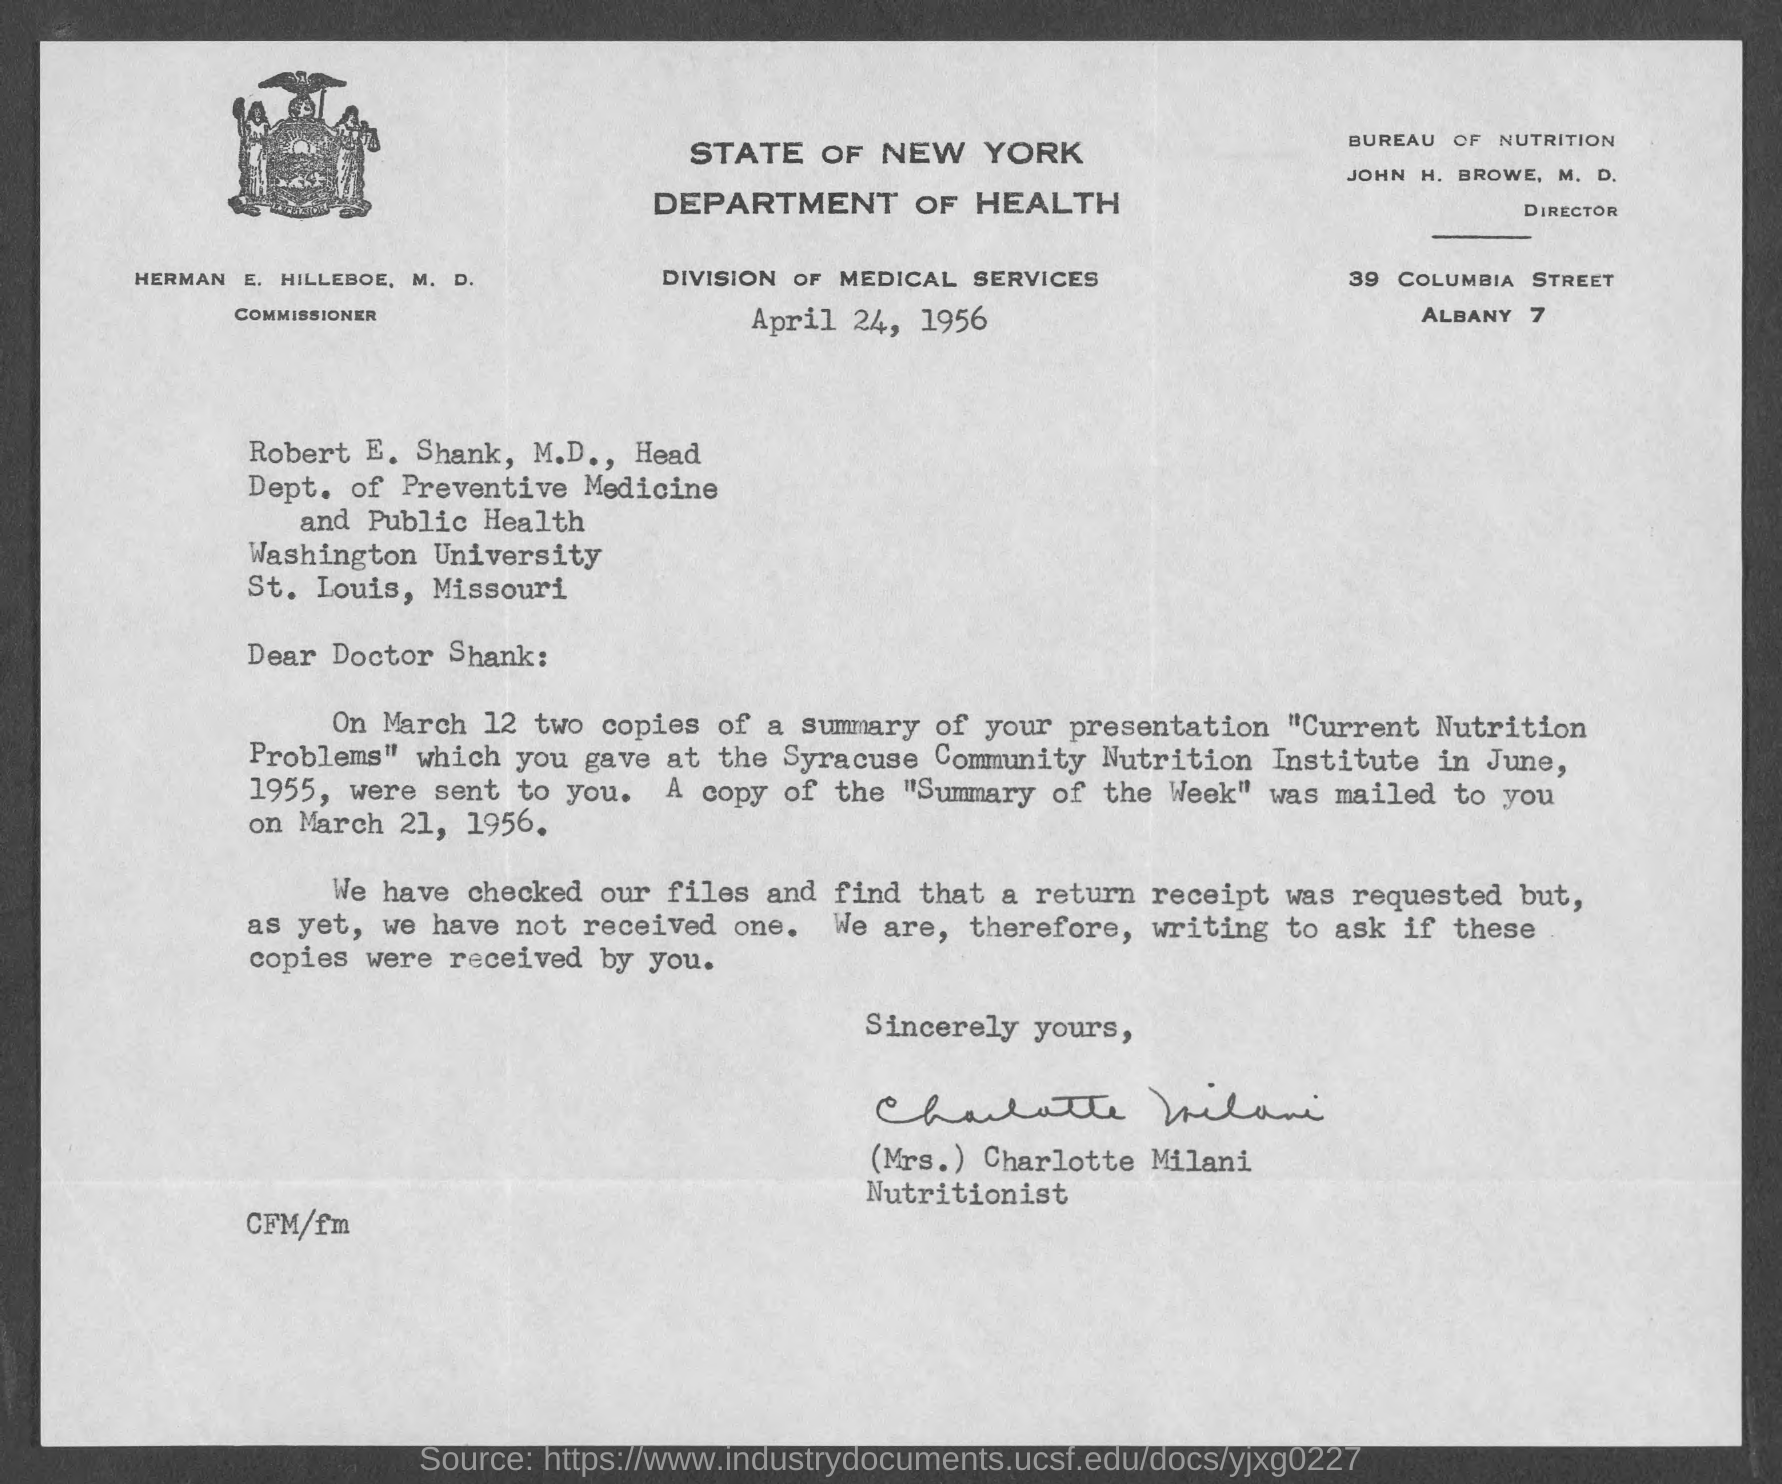Who is the Director of Bureau of Nutrition?
Make the answer very short. John H. Browe. Who has signed this letter?
Your response must be concise. (Mrs.) Charlotte Milani. What is the designation of (Mrs.) Charlotte Milani?
Ensure brevity in your answer.  Nutritionist. Who is the addressee of this letter?
Provide a succinct answer. Robert E. Shank,  M.D. What is the designation of Robert E. Shank,  M.D.?
Offer a terse response. Head, Department of Preventive Medicine and Public Health. What is the designation of HERMAN E. HILLEBOE, M. D.?
Your answer should be compact. COMMISSIONER. When was the copy of the "Summary of the Week" mailed to Doctor Shank?
Offer a terse response. March 21, 1956. 